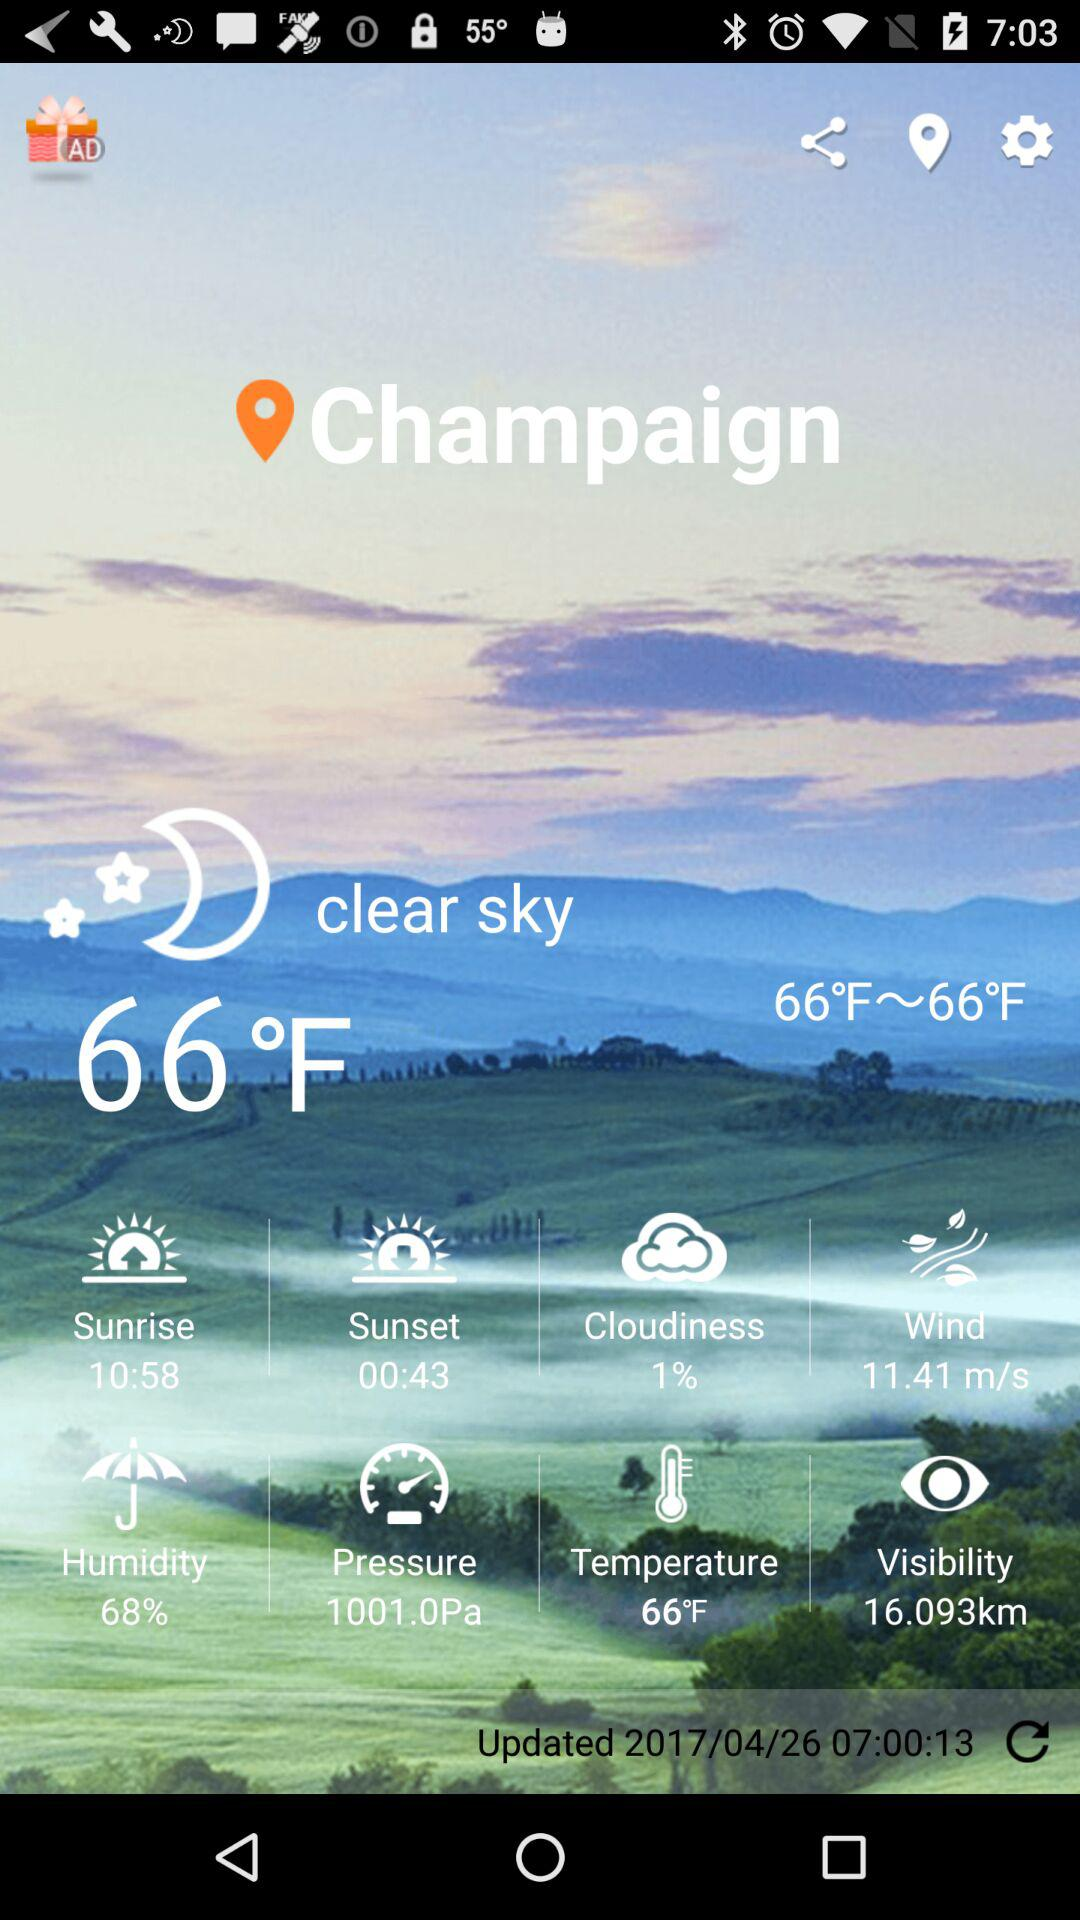When was it last updated? It was last updated on April 26 2017 at 07:00:13. 